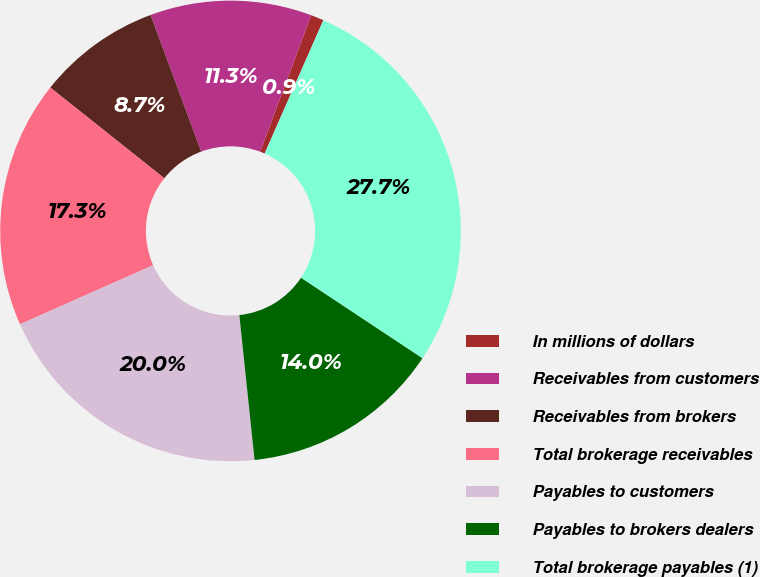<chart> <loc_0><loc_0><loc_500><loc_500><pie_chart><fcel>In millions of dollars<fcel>Receivables from customers<fcel>Receivables from brokers<fcel>Total brokerage receivables<fcel>Payables to customers<fcel>Payables to brokers dealers<fcel>Total brokerage payables (1)<nl><fcel>0.91%<fcel>11.34%<fcel>8.66%<fcel>17.34%<fcel>20.02%<fcel>14.02%<fcel>27.71%<nl></chart> 